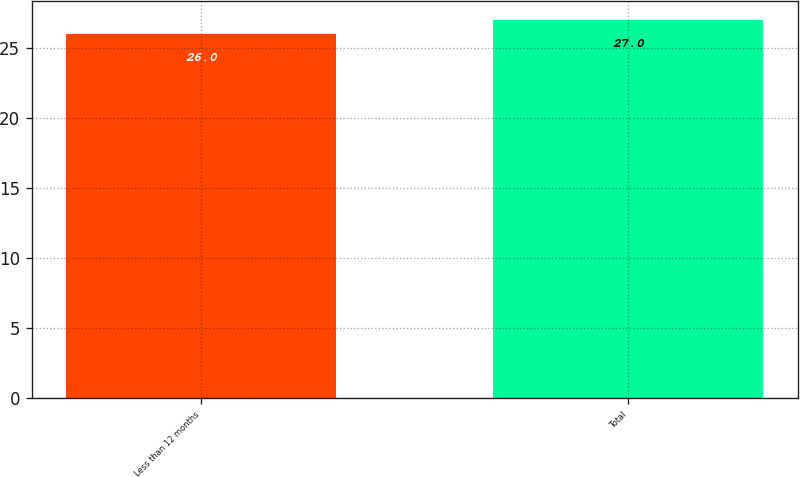Convert chart to OTSL. <chart><loc_0><loc_0><loc_500><loc_500><bar_chart><fcel>Less than 12 months<fcel>Total<nl><fcel>26<fcel>27<nl></chart> 